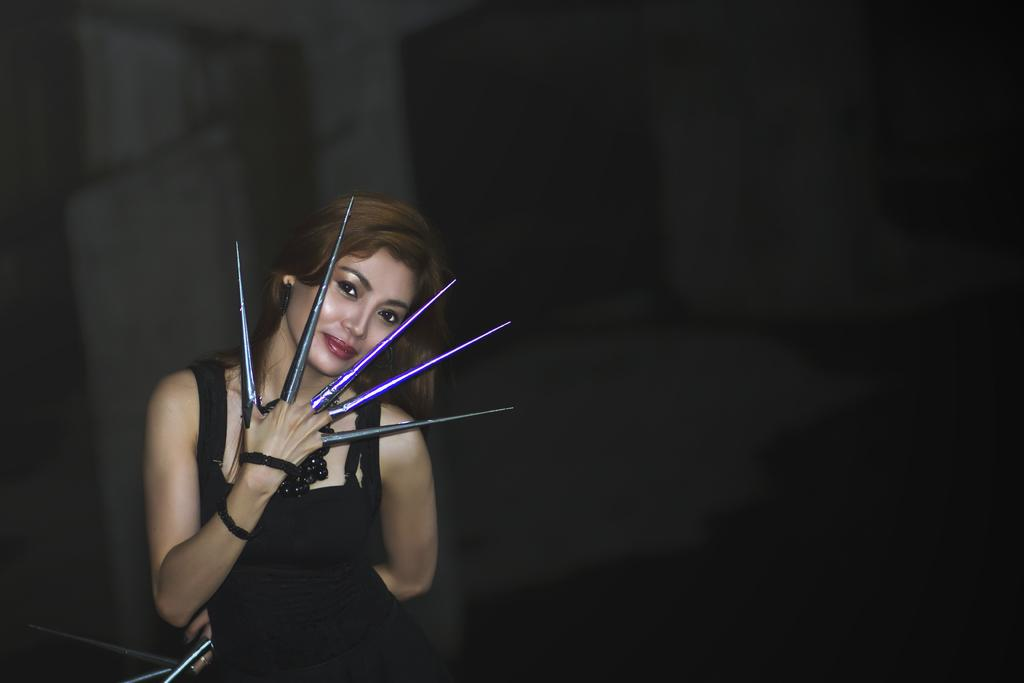What is the main subject of the image? The main subject of the image is women standing. What are the women wearing on their fingers? The women are wearing accessories on their fingers. What type of watch is the monkey wearing in the image? There is no monkey or watch present in the image. How does the image convey respect among the women? The image does not convey respect among the women, as there is no context or interaction depicted. 